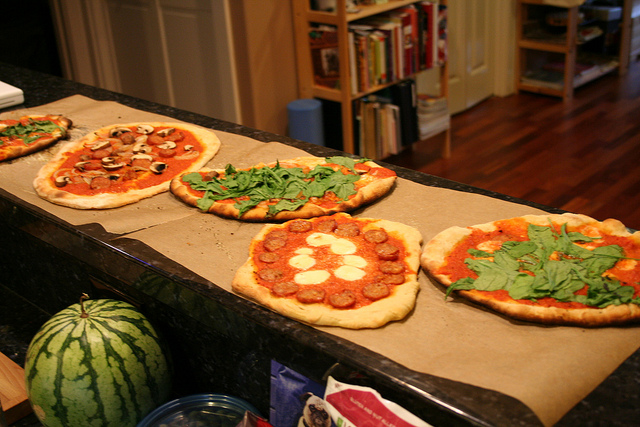<image>Which of these would you prefer to eat? It is ambiguous to determine preference as it depends on individual taste. Which of these would you prefer to eat? I don't know which of these you would prefer to eat. It can be either pepperoni, spinach or pizza. 